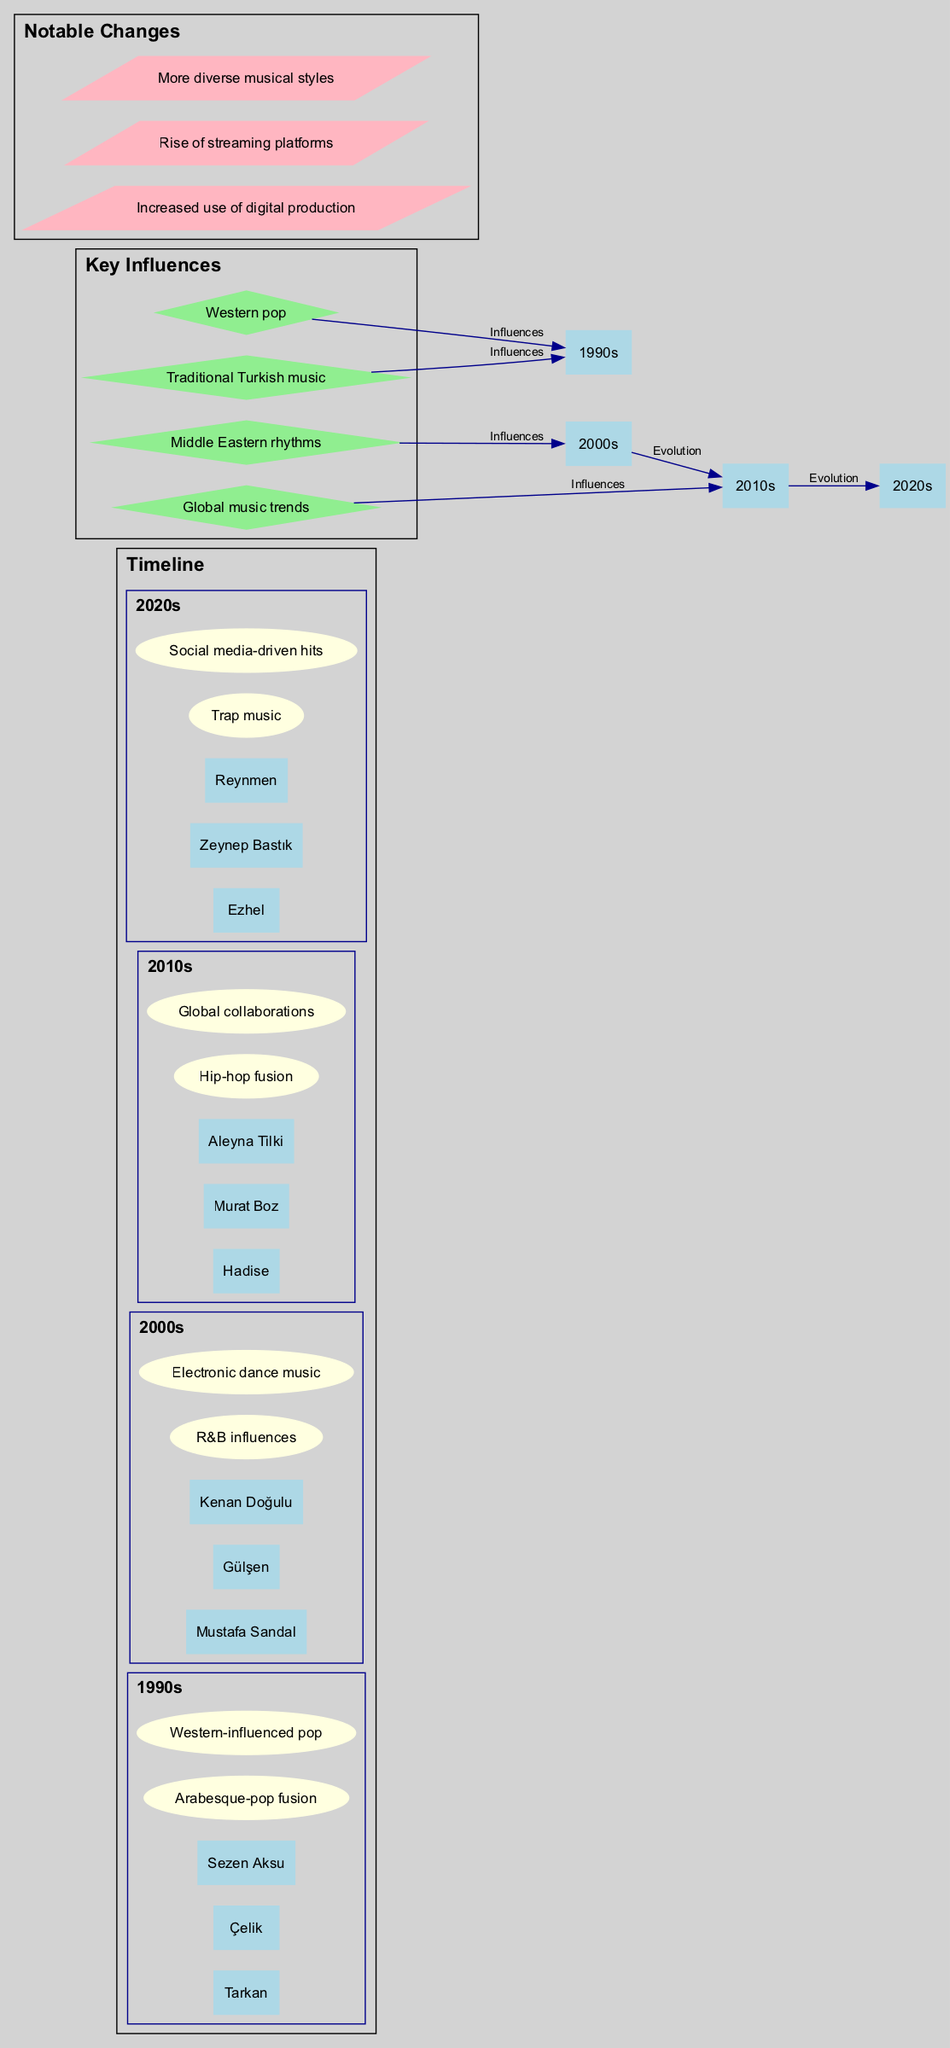What artists are listed for the 1990s? The diagram shows a subgraph for the 1990s, where the artists 'Tarkan', 'Çelik', and 'Sezen Aksu' are nodes. These names are directly connected as the artists representative of that decade.
Answer: Tarkan, Çelik, Sezen Aksu How many trends are mentioned for the 2000s? In the 2000s subgraph, there are two distinct nodes representing the trends: 'R&B influences' and 'Electronic dance music'. By counting these, we find that there are two trends represented.
Answer: 2 Which influential factors are connected to the 2010s? The diagram indicates the 'Global music trends' node is linked to the 2010s through an edge representing its influence on that decade. Additionally, it can be inferred that 'Western pop' and other factors were also influential in earlier decades but not specifically connected to the 2010s.
Answer: Global music trends What is the notable change related to music production techniques? By examining the cluster labeled 'Notable Changes', the entry 'Increased use of digital production' is present, denoting this specific change in music production techniques.
Answer: Increased use of digital production Which artists debuted in the 2020s? The 2020s subgraph lists 'Ezhel', 'Zeynep Bastık', and 'Reynmen' as the key artists emerging during that decade. This information can be found directly within that specific section of the diagram.
Answer: Ezhel, Zeynep Bastık, Reynmen What are the main musical trends highlighted for the 2010s? In the 2010s subgraph, the trends noted are 'Hip-hop fusion' and 'Global collaborations'. These areas reflect significant developments in the music of that decade as shown in the diagram.
Answer: Hip-hop fusion, Global collaborations What connects the 2000s to the 2010s? The diagram features an edge labeled 'Evolution' between the nodes for the 2000s and the 2010s, indicating a relationship of development or change from one decade to another in terms of music.
Answer: Evolution How many key influences are highlighted in the diagram? The diagram presents four distinct nodes under the 'Key Influences' cluster: 'Western pop', 'Traditional Turkish music', 'Middle Eastern rhythms', and 'Global music trends'. By counting these, we determine there are four key influences.
Answer: 4 